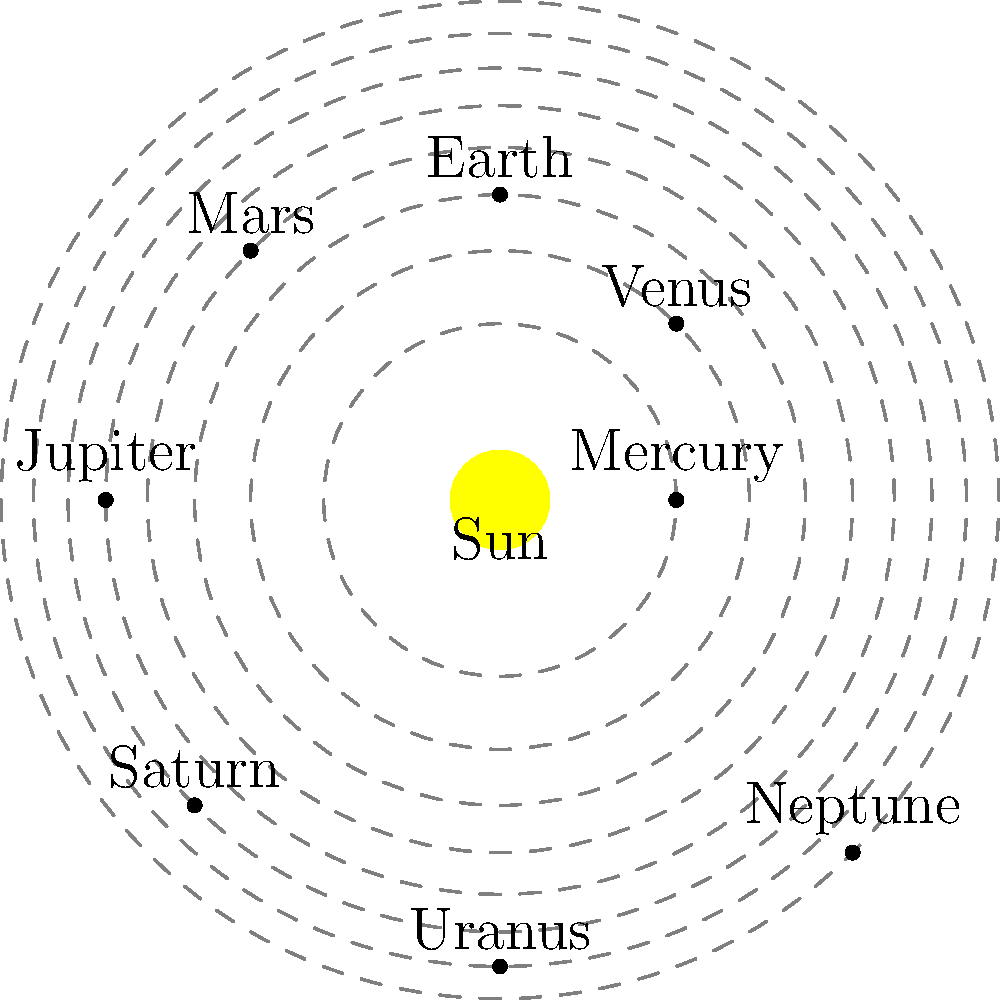In the context of game development for an immersive single-player experience, you're designing a space exploration game. Which planet would be the most challenging to reach if your spaceship's fuel capacity is directly proportional to the planet's distance from the Sun, and you want to maximize the difficulty for players? To determine the most challenging planet to reach, we need to consider the distances of the planets from the Sun. In our solar system, the order of planets from the Sun is:

1. Mercury
2. Venus
3. Earth
4. Mars
5. Jupiter
6. Saturn
7. Uranus
8. Neptune

The distance from the Sun increases as we move outward. In the diagram, the orbits are represented by dashed circles, with the outermost orbit being the furthest from the Sun.

Since the fuel capacity is directly proportional to the planet's distance from the Sun, the furthest planet would require the most fuel and thus be the most challenging to reach. This would create the highest difficulty for players in a space exploration game.

Looking at the diagram and considering the order of planets, we can see that Neptune is positioned on the outermost orbit, making it the furthest planet from the Sun in our solar system.

Therefore, Neptune would be the most challenging planet to reach in this game scenario, providing the maximum difficulty for players and contributing to an immersive single-player experience.
Answer: Neptune 